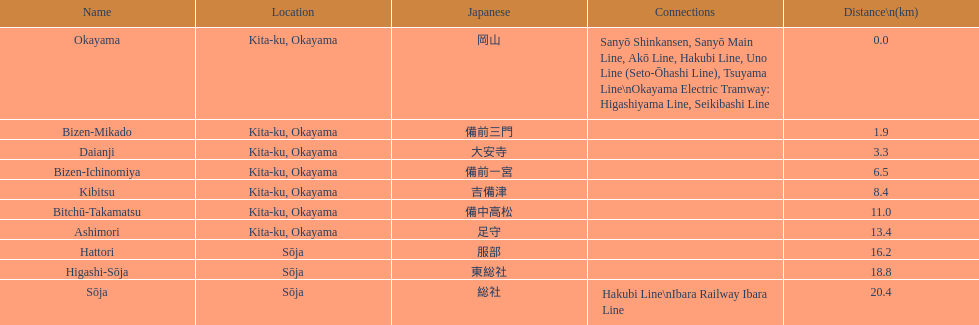What's the count of stations having a distance under 15km? 7. 